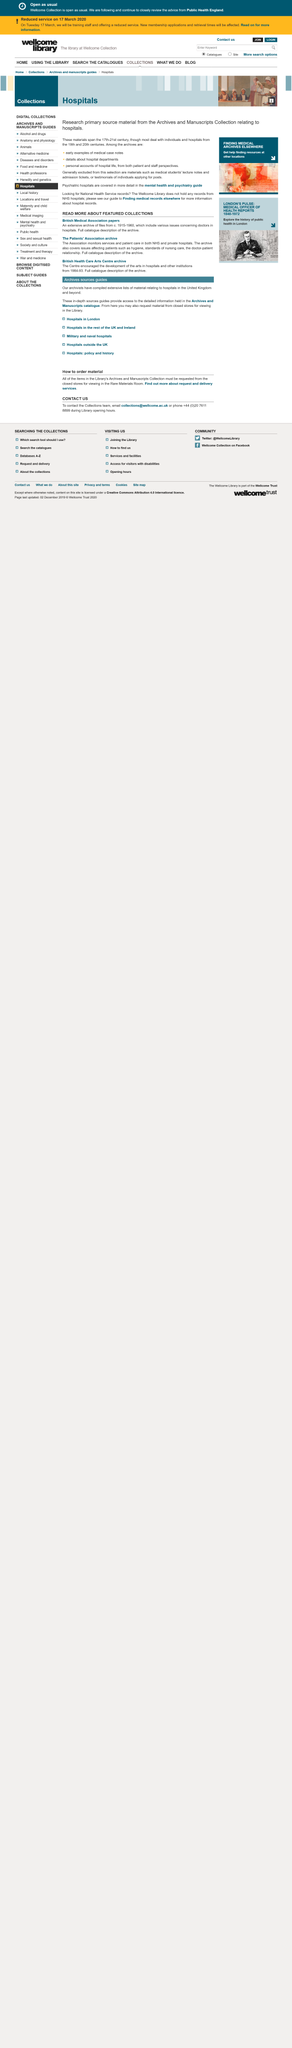Point out several critical features in this image. The British Medical Association papers cover a time period ranging from approximately 1915 to 1960. The Patients Association monitors services and patient care in both the NHS and private hospitals to ensure the safety and well-being of patients. The patients association does not monitor technology improvements in hospitals directly, but it monitors any factors that may have an impact on patients, whether directly or indirectly. 